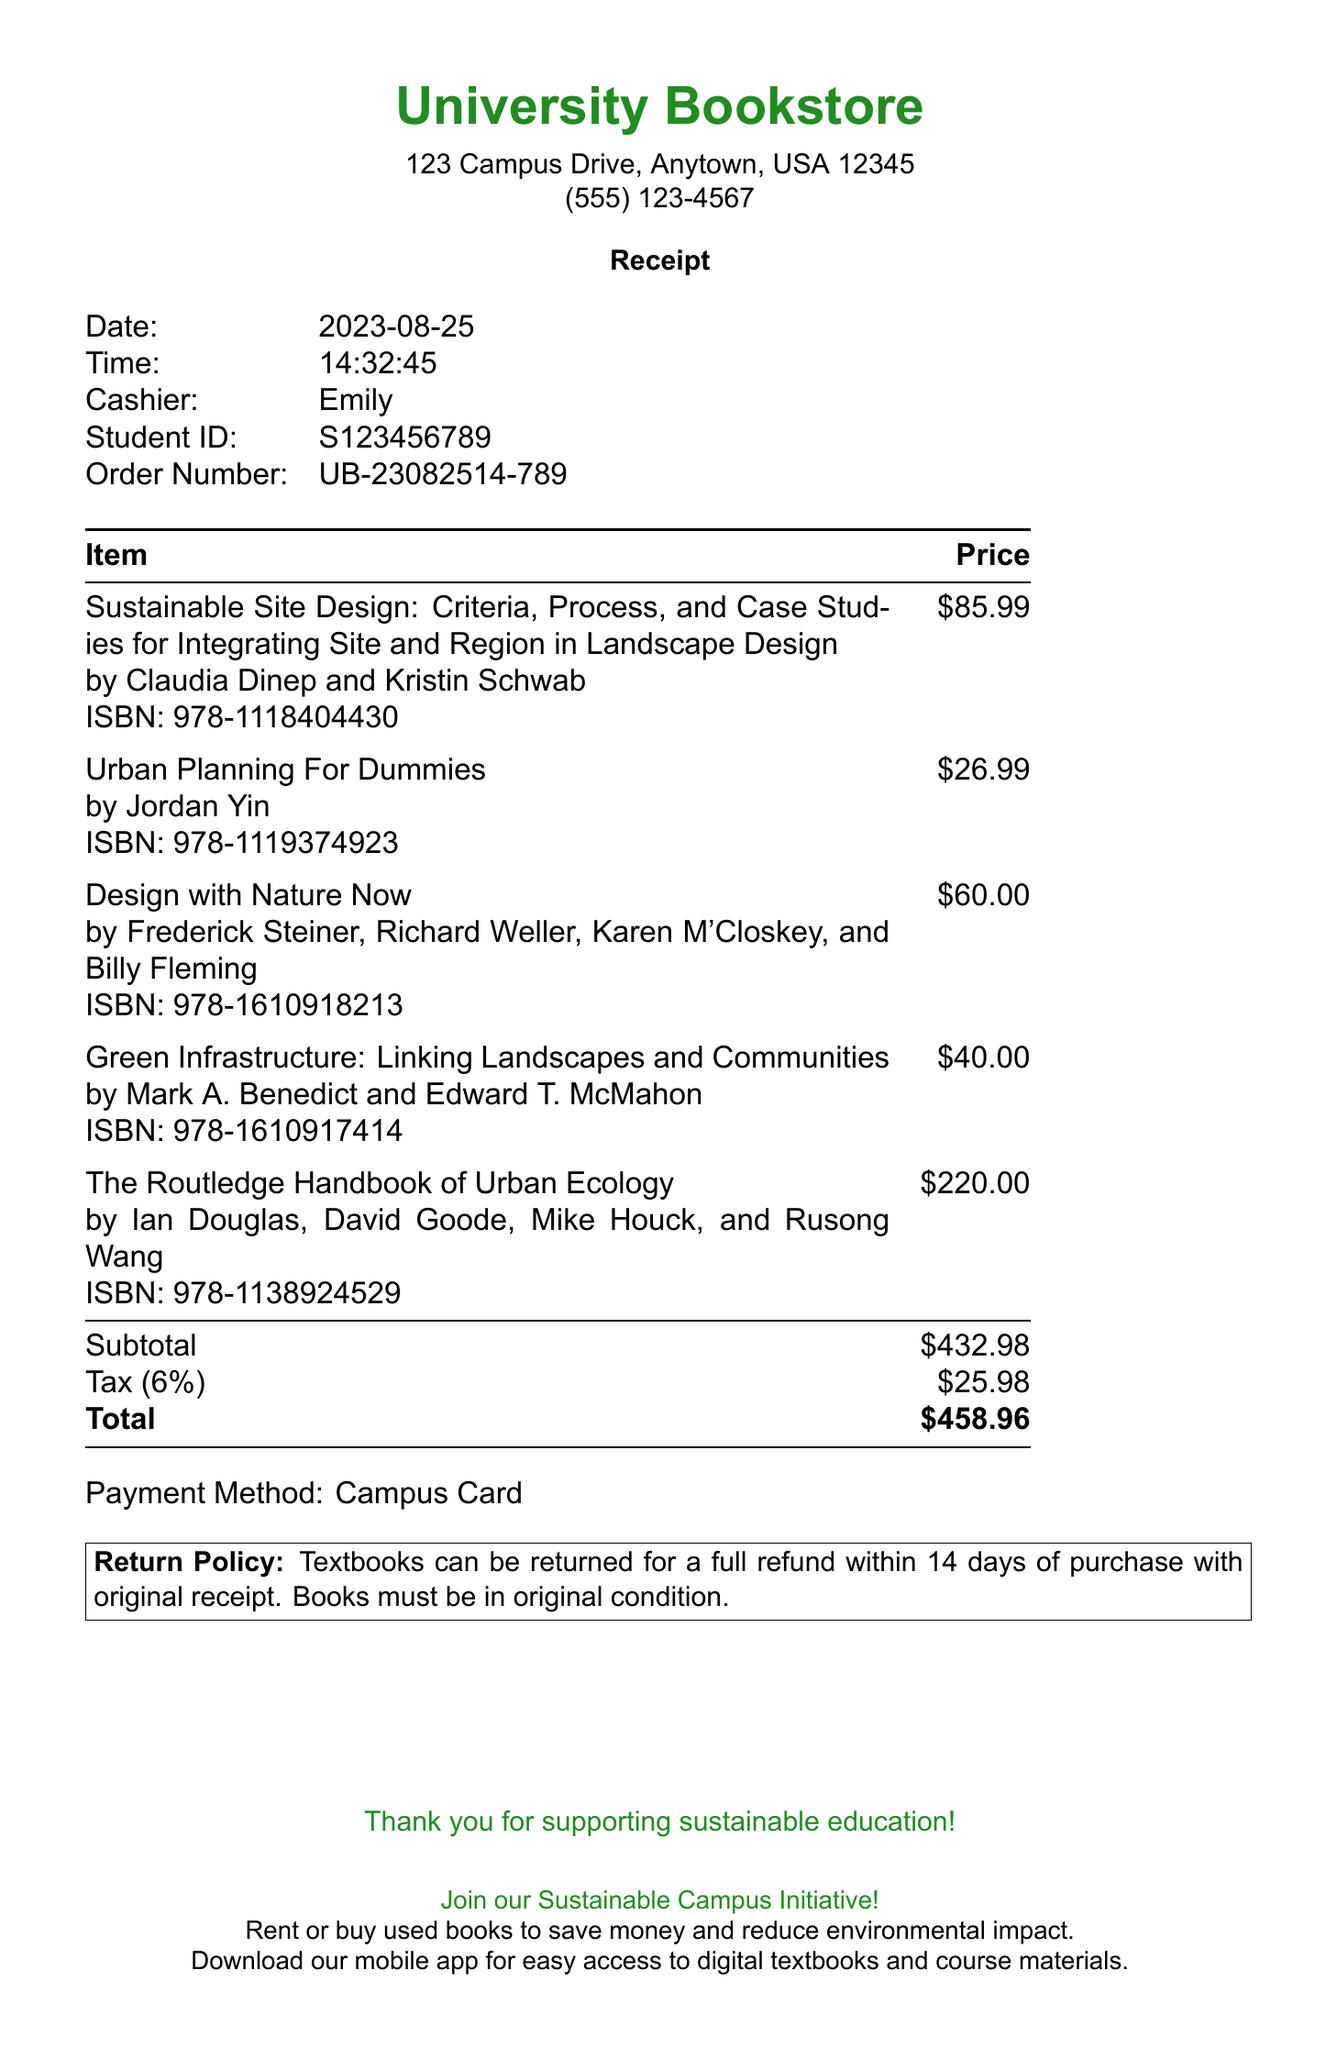what is the store name? The store name is found at the top of the receipt.
Answer: University Bookstore what is the subtotal amount? The subtotal is the amount before tax, listed in the document.
Answer: $432.98 who is the cashier? The cashier's name is mentioned in the receipt details.
Answer: Emily what is the date of the purchase? The date of purchase is specified in the receipt header.
Answer: 2023-08-25 how many items are listed in the receipt? The number of items can be counted from the list provided in the document.
Answer: 5 what is the return policy? The return policy is stated at the bottom of the receipt.
Answer: Textbooks can be returned for a full refund within 14 days of purchase with original receipt what is the total amount paid? The total amount is clearly labeled at the end of the table.
Answer: $458.96 which textbook has the highest price? The highest price is found by comparing the prices of all items listed.
Answer: The Routledge Handbook of Urban Ecology what payment method was used? The payment method is mentioned in the receipt details.
Answer: Campus Card 